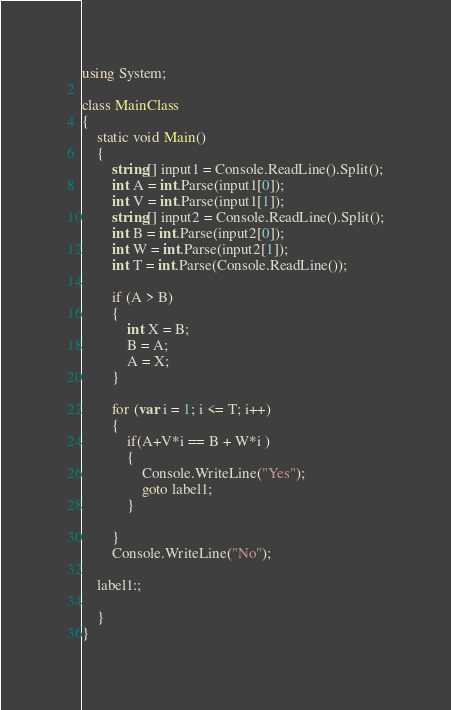Convert code to text. <code><loc_0><loc_0><loc_500><loc_500><_C#_>using System;

class MainClass
{
    static void Main()
    {
        string[] input1 = Console.ReadLine().Split();
        int A = int.Parse(input1[0]);
        int V = int.Parse(input1[1]);
        string[] input2 = Console.ReadLine().Split();
        int B = int.Parse(input2[0]);
        int W = int.Parse(input2[1]);
        int T = int.Parse(Console.ReadLine());

        if (A > B)
        {
            int X = B;
            B = A;
            A = X;
        }

        for (var i = 1; i <= T; i++)
        {
            if(A+V*i == B + W*i )
            {
                Console.WriteLine("Yes");
                goto label1;
            }

        }
        Console.WriteLine("No");

    label1:;

    }
}</code> 